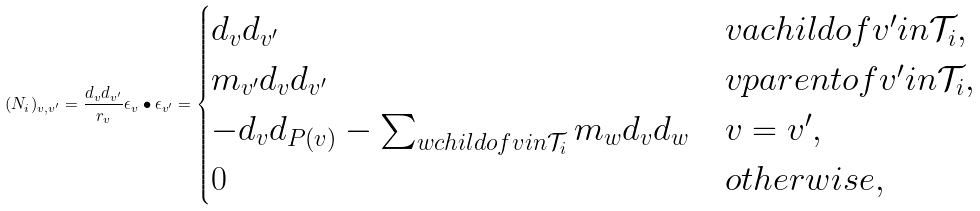<formula> <loc_0><loc_0><loc_500><loc_500>( N _ { i } ) _ { v , v ^ { \prime } } = \frac { d _ { v } d _ { v ^ { \prime } } } { r _ { v } } \epsilon _ { v } \bullet \epsilon _ { v ^ { \prime } } = \begin{cases} d _ { v } d _ { v ^ { \prime } } & v a c h i l d o f v ^ { \prime } i n \mathcal { T } _ { i } , \\ m _ { v ^ { \prime } } d _ { v } d _ { v ^ { \prime } } & v p a r e n t o f v ^ { \prime } i n \mathcal { T } _ { i } , \\ - d _ { v } d _ { P ( v ) } - \sum _ { w c h i l d o f v i n \mathcal { T } _ { i } } m _ { w } d _ { v } d _ { w } & v = v ^ { \prime } , \\ 0 & o t h e r w i s e , \end{cases}</formula> 